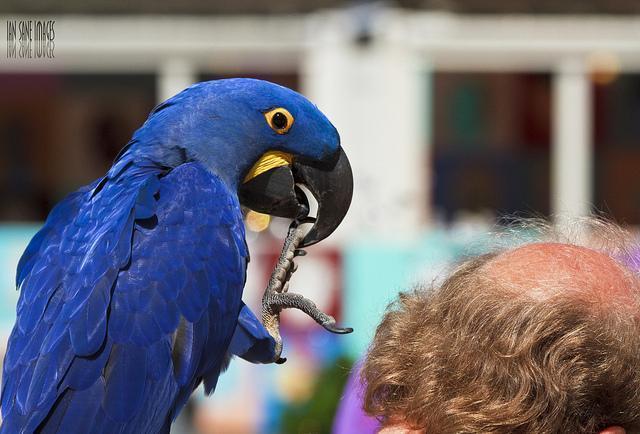Does the image validate the caption "The bird is at the back of the person."?
Answer yes or no. Yes. 